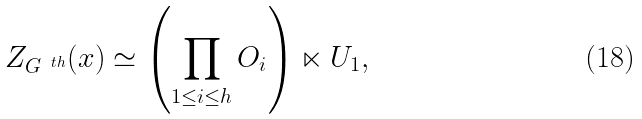Convert formula to latex. <formula><loc_0><loc_0><loc_500><loc_500>Z _ { G ^ { \ t h } } ( x ) \simeq \left ( \prod _ { 1 \leq i \leq h } O _ { i } \right ) \ltimes U _ { 1 } ,</formula> 